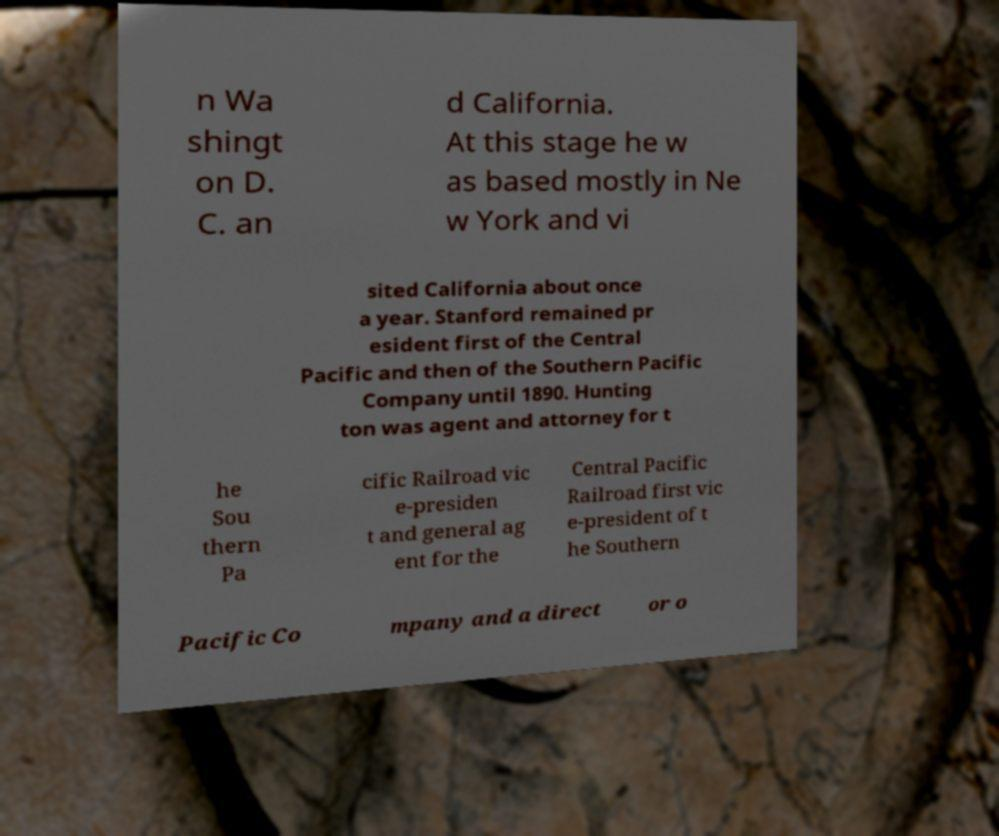Can you accurately transcribe the text from the provided image for me? n Wa shingt on D. C. an d California. At this stage he w as based mostly in Ne w York and vi sited California about once a year. Stanford remained pr esident first of the Central Pacific and then of the Southern Pacific Company until 1890. Hunting ton was agent and attorney for t he Sou thern Pa cific Railroad vic e-presiden t and general ag ent for the Central Pacific Railroad first vic e-president of t he Southern Pacific Co mpany and a direct or o 